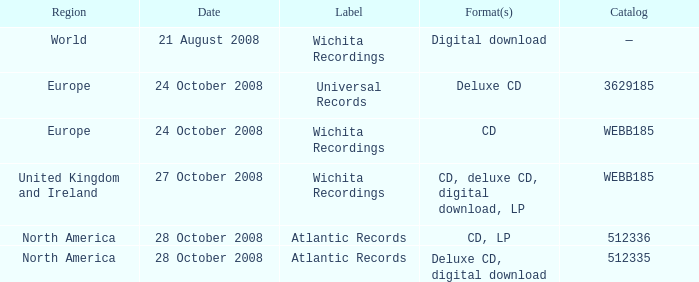To which region is the catalog value 512335 related? North America. 